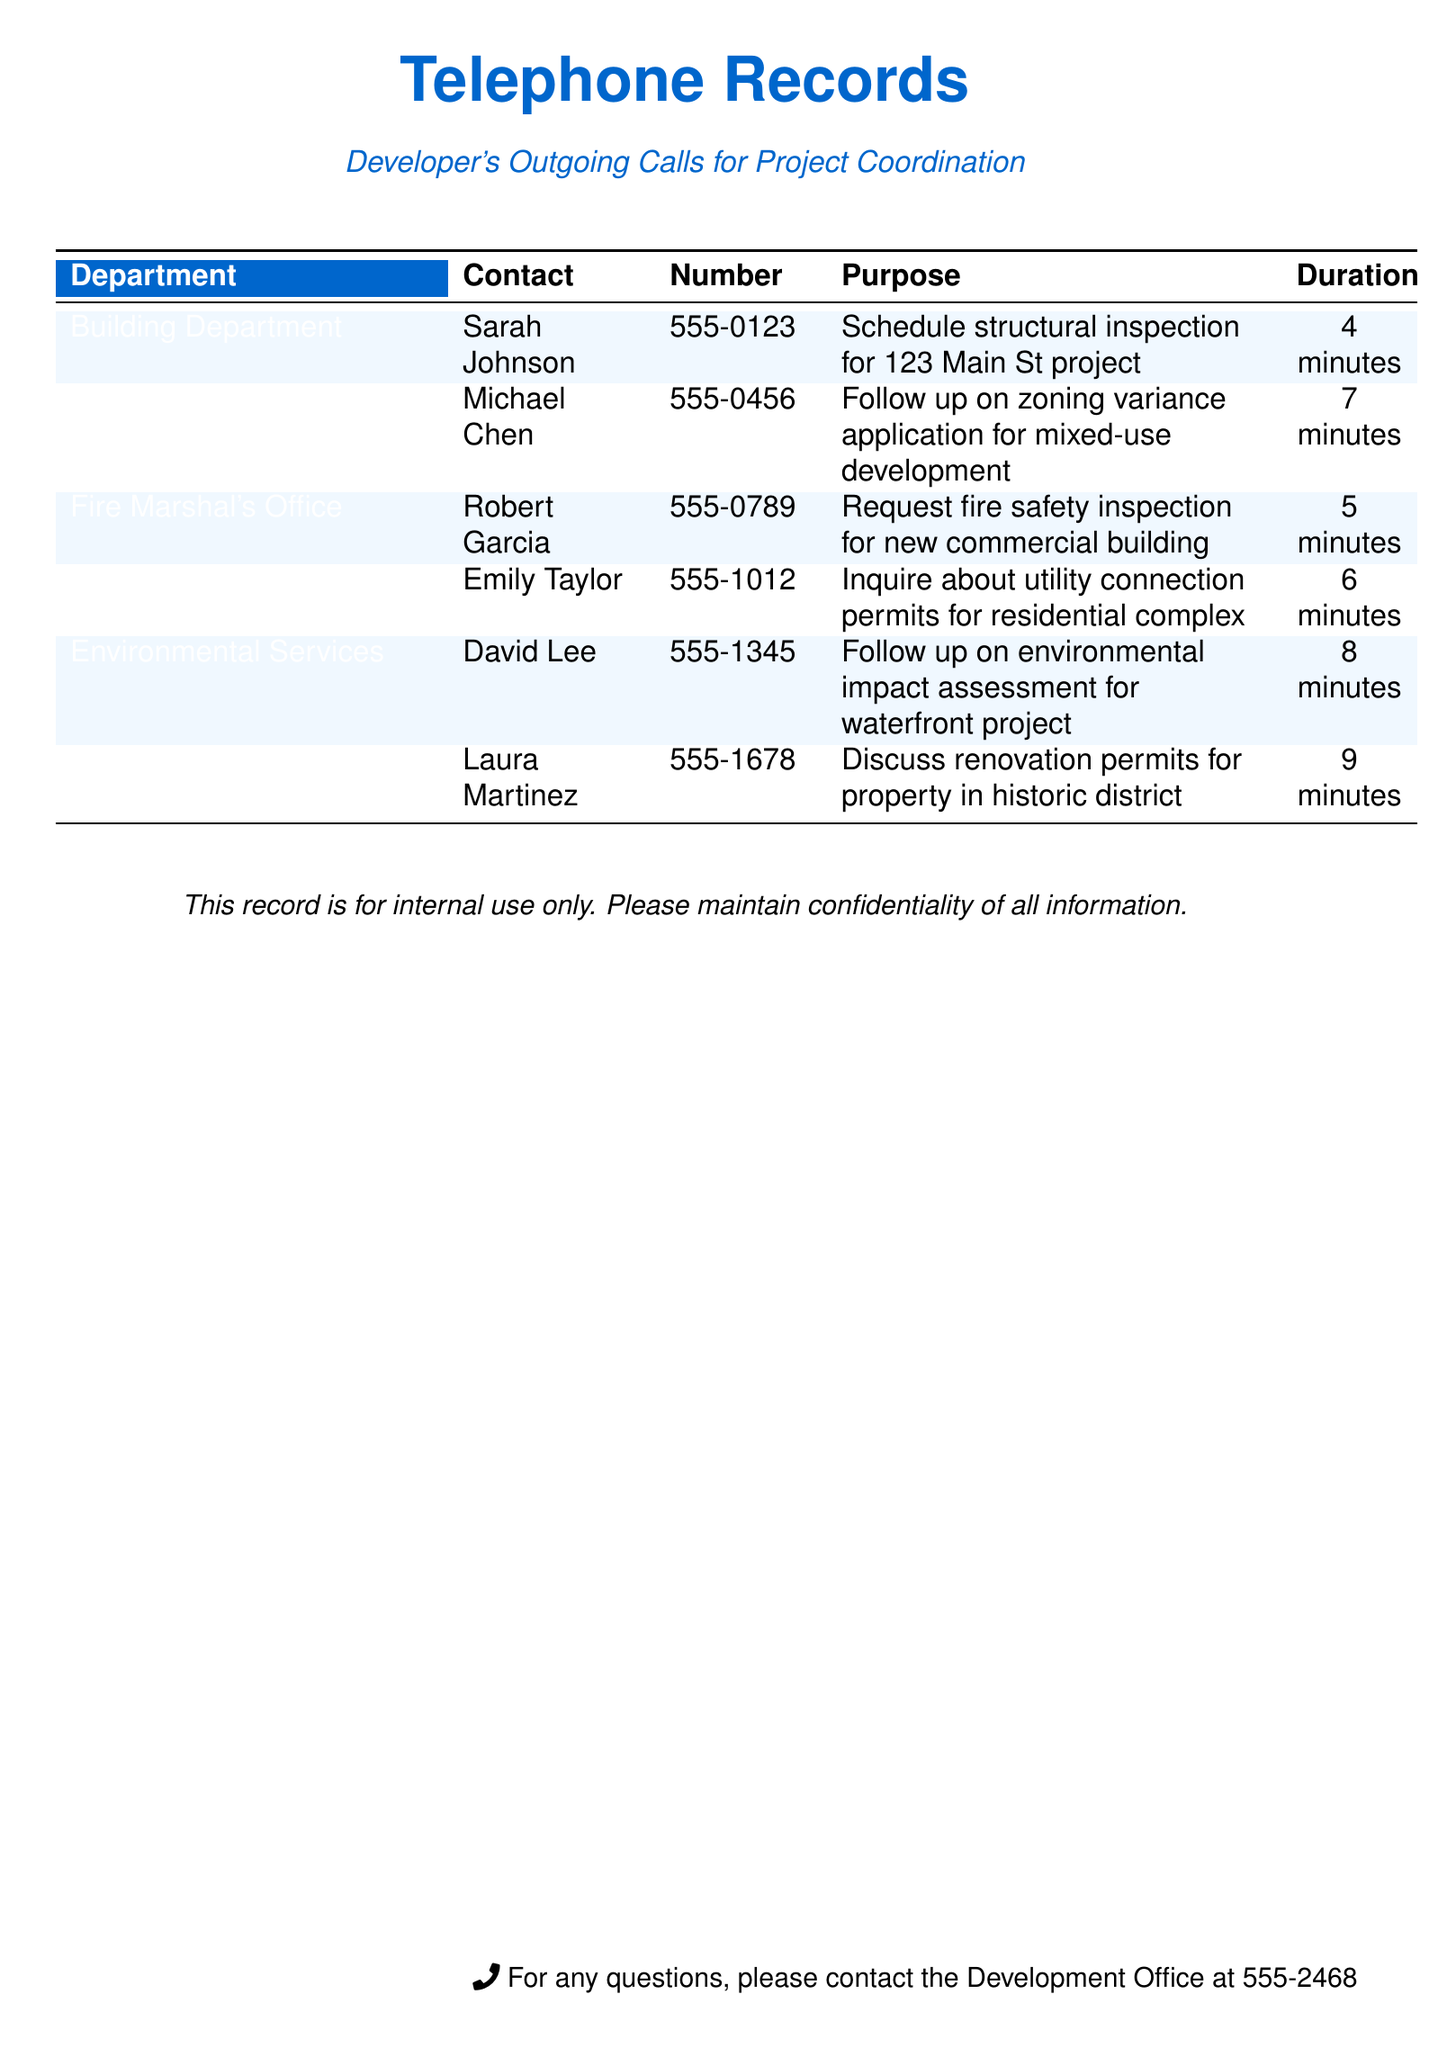What is the phone number for the Building Department? The phone number for the Building Department is listed in the document.
Answer: 555-0123 Who did the developer contact at the Planning Division? The document provides the name of the contact person in the Planning Division.
Answer: Michael Chen How long was the conversation with the Fire Marshal's Office? The duration of the call to the Fire Marshal's Office is recorded in the document.
Answer: 5 minutes What is the purpose of the call to the Environmental Services? The document states the reason for the call to Environmental Services.
Answer: Follow up on environmental impact assessment for waterfront project Which department was contacted regarding historic district renovation permits? The document specifies the department the developer contacted for renovation permits.
Answer: Historic Preservation Office What is the total call duration time for all listed departments? To determine the total call duration, individual durations need to be added together as listed in the document.
Answer: 39 minutes Which department is responsible for utility connection permits? The document identifies the department related to utility connection permits.
Answer: Public Works What was the outcome expected from the call to the Fire Marshal's Office? The document outlines the expected outcome related to the call to the Fire Marshal's Office.
Answer: Request fire safety inspection 